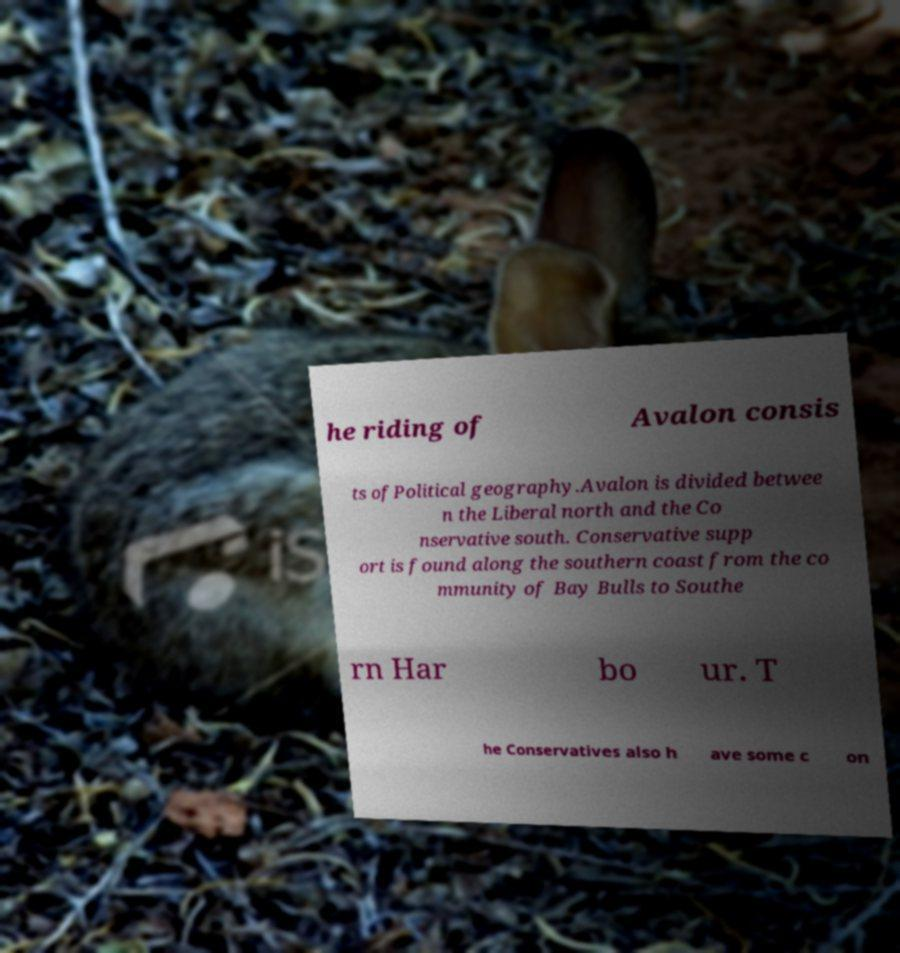Could you assist in decoding the text presented in this image and type it out clearly? he riding of Avalon consis ts ofPolitical geography.Avalon is divided betwee n the Liberal north and the Co nservative south. Conservative supp ort is found along the southern coast from the co mmunity of Bay Bulls to Southe rn Har bo ur. T he Conservatives also h ave some c on 